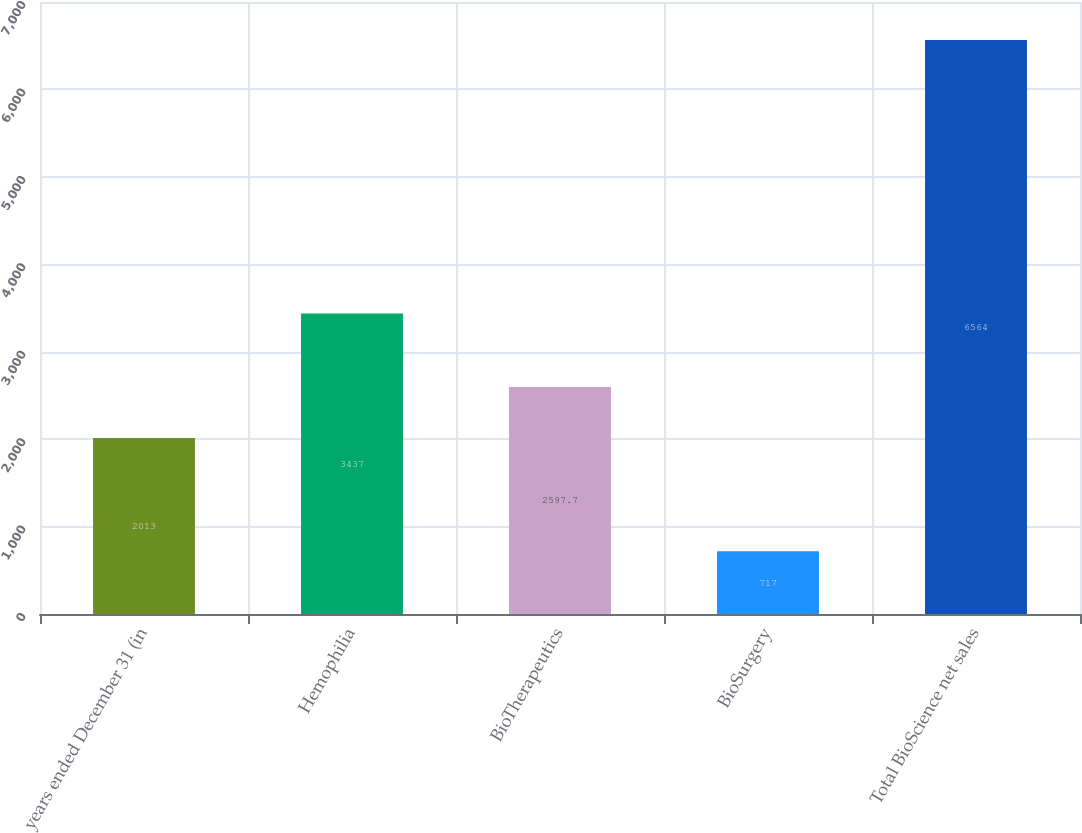Convert chart. <chart><loc_0><loc_0><loc_500><loc_500><bar_chart><fcel>years ended December 31 (in<fcel>Hemophilia<fcel>BioTherapeutics<fcel>BioSurgery<fcel>Total BioScience net sales<nl><fcel>2013<fcel>3437<fcel>2597.7<fcel>717<fcel>6564<nl></chart> 